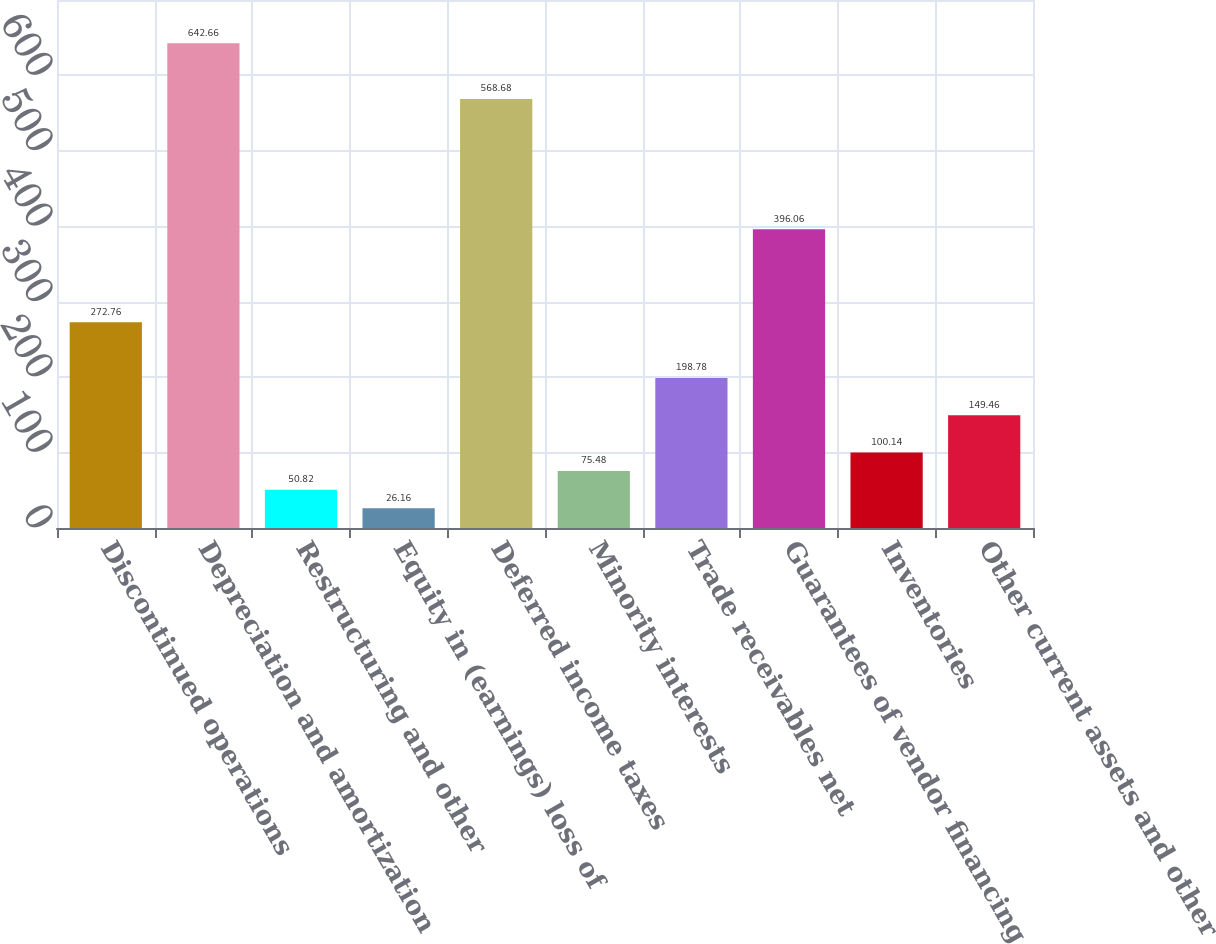Convert chart. <chart><loc_0><loc_0><loc_500><loc_500><bar_chart><fcel>Discontinued operations<fcel>Depreciation and amortization<fcel>Restructuring and other<fcel>Equity in (earnings) loss of<fcel>Deferred income taxes<fcel>Minority interests<fcel>Trade receivables net<fcel>Guarantees of vendor financing<fcel>Inventories<fcel>Other current assets and other<nl><fcel>272.76<fcel>642.66<fcel>50.82<fcel>26.16<fcel>568.68<fcel>75.48<fcel>198.78<fcel>396.06<fcel>100.14<fcel>149.46<nl></chart> 